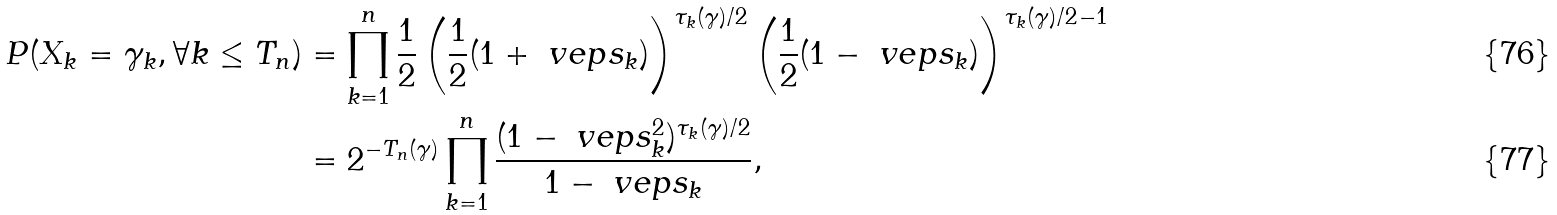Convert formula to latex. <formula><loc_0><loc_0><loc_500><loc_500>P ( X _ { k } = \gamma _ { k } , \forall k \leq T _ { n } ) & = \prod _ { k = 1 } ^ { n } \frac { 1 } { 2 } \left ( \frac { 1 } { 2 } ( 1 + \ v e p s _ { k } ) \right ) ^ { \tau _ { k } ( \gamma ) / 2 } \left ( \frac { 1 } { 2 } ( 1 - \ v e p s _ { k } ) \right ) ^ { \tau _ { k } ( \gamma ) / 2 - 1 } \\ & = 2 ^ { - T _ { n } ( \gamma ) } \prod _ { k = 1 } ^ { n } \frac { ( 1 - \ v e p s _ { k } ^ { 2 } ) ^ { \tau _ { k } ( \gamma ) / 2 } } { 1 - \ v e p s _ { k } } ,</formula> 